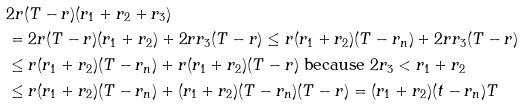Convert formula to latex. <formula><loc_0><loc_0><loc_500><loc_500>& 2 r ( T - r ) ( r _ { 1 } + r _ { 2 } + r _ { 3 } ) \\ & = 2 r ( T - r ) ( r _ { 1 } + r _ { 2 } ) + 2 r r _ { 3 } ( T - r ) \leq r ( r _ { 1 } + r _ { 2 } ) ( T - r _ { n } ) + 2 r r _ { 3 } ( T - r ) \\ & \leq r ( r _ { 1 } + r _ { 2 } ) ( T - r _ { n } ) + r ( r _ { 1 } + r _ { 2 } ) ( T - r ) \text { because } 2 r _ { 3 } < r _ { 1 } + r _ { 2 } \\ & \leq r ( r _ { 1 } + r _ { 2 } ) ( T - r _ { n } ) + ( r _ { 1 } + r _ { 2 } ) ( T - r _ { n } ) ( T - r ) = ( r _ { 1 } + r _ { 2 } ) ( t - r _ { n } ) T</formula> 